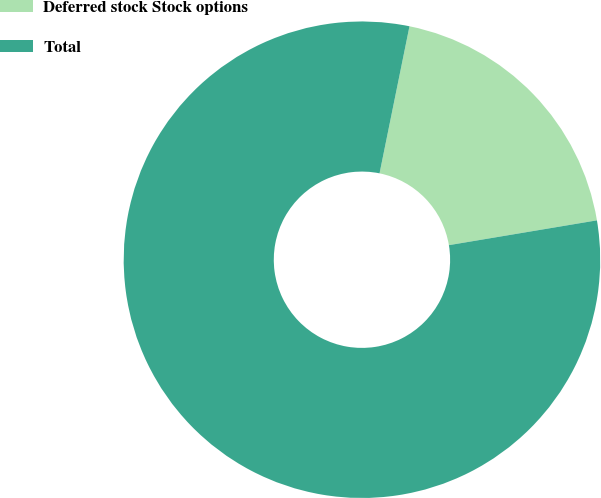Convert chart to OTSL. <chart><loc_0><loc_0><loc_500><loc_500><pie_chart><fcel>Deferred stock Stock options<fcel>Total<nl><fcel>19.16%<fcel>80.84%<nl></chart> 